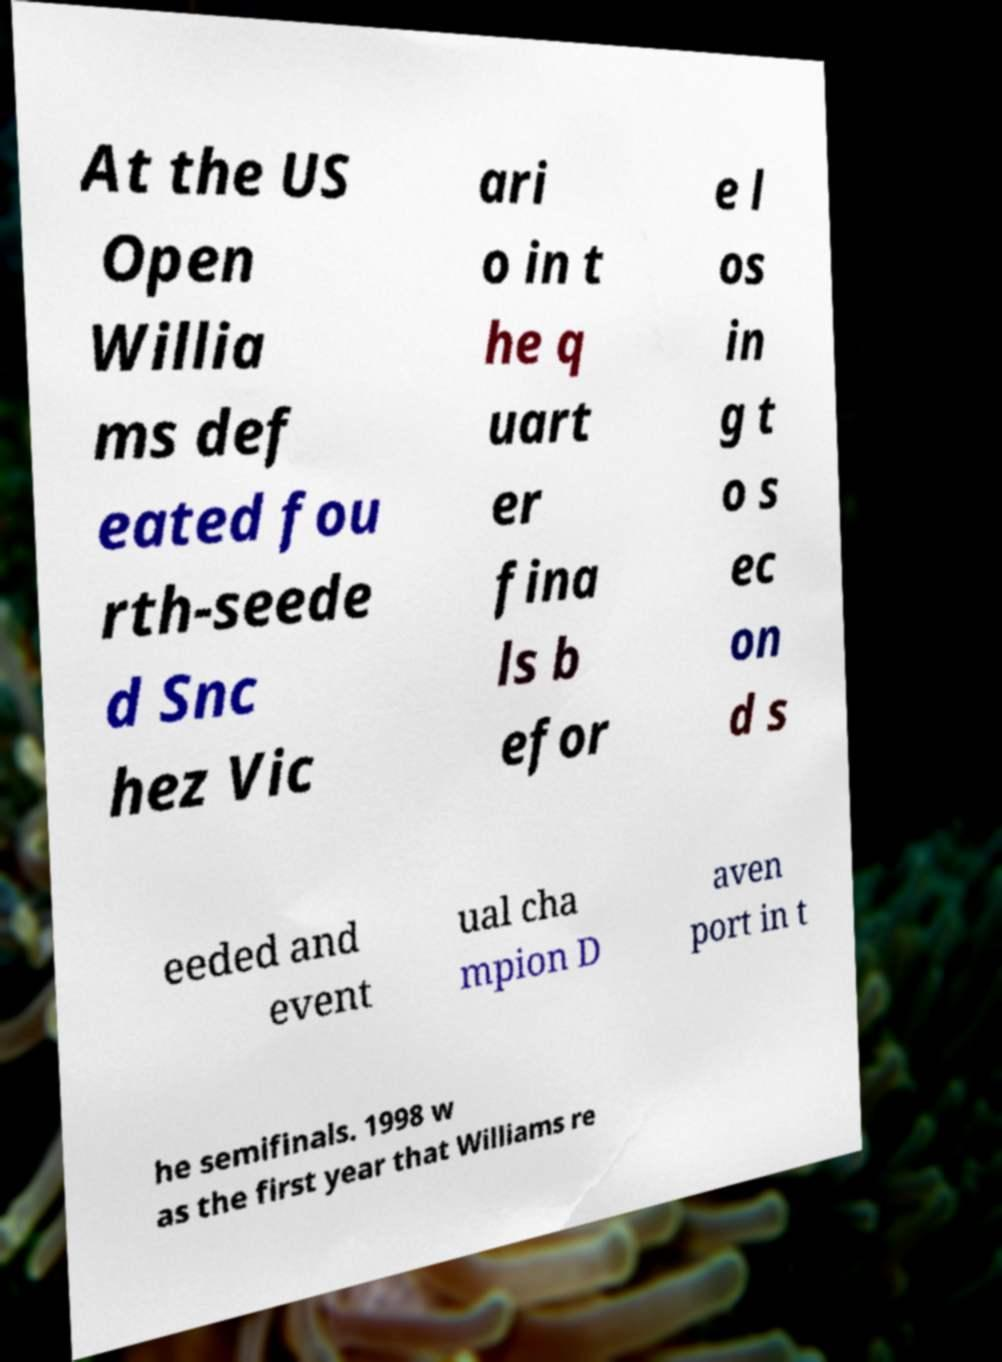Can you read and provide the text displayed in the image?This photo seems to have some interesting text. Can you extract and type it out for me? At the US Open Willia ms def eated fou rth-seede d Snc hez Vic ari o in t he q uart er fina ls b efor e l os in g t o s ec on d s eeded and event ual cha mpion D aven port in t he semifinals. 1998 w as the first year that Williams re 